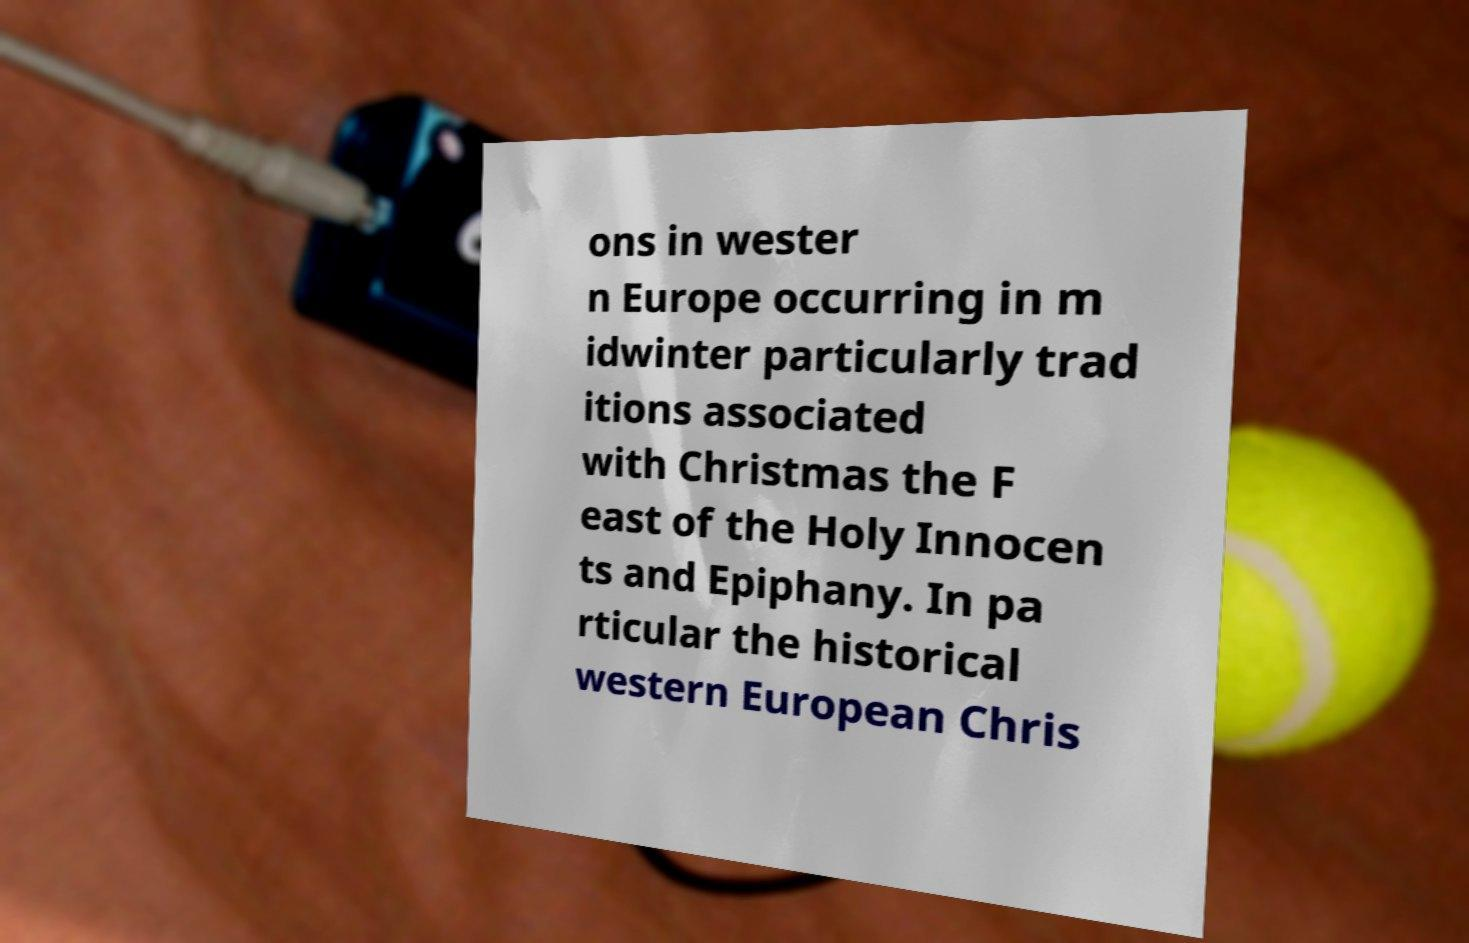Can you accurately transcribe the text from the provided image for me? ons in wester n Europe occurring in m idwinter particularly trad itions associated with Christmas the F east of the Holy Innocen ts and Epiphany. In pa rticular the historical western European Chris 